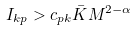<formula> <loc_0><loc_0><loc_500><loc_500>I _ { k p } > c _ { p k } \bar { K } M ^ { 2 - \alpha }</formula> 